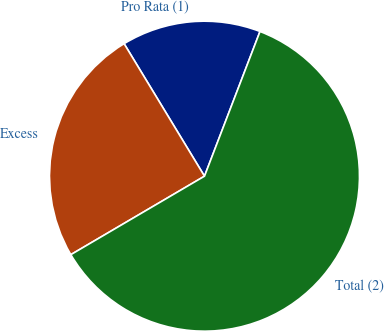<chart> <loc_0><loc_0><loc_500><loc_500><pie_chart><fcel>Pro Rata (1)<fcel>Excess<fcel>Total (2)<nl><fcel>14.51%<fcel>24.77%<fcel>60.72%<nl></chart> 